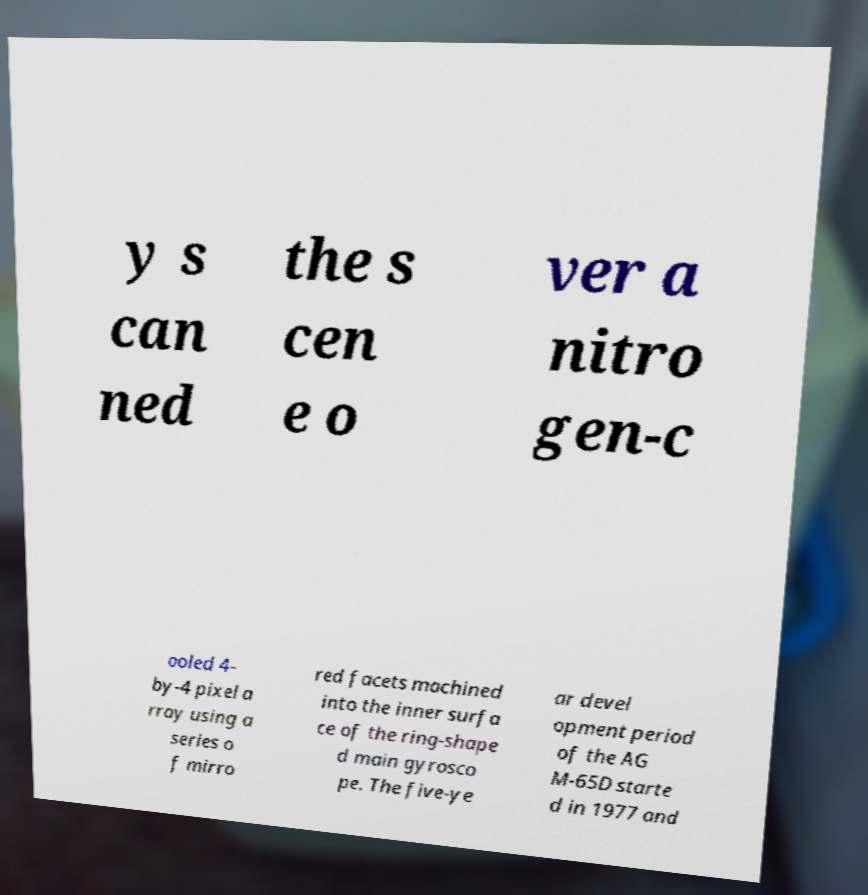Can you accurately transcribe the text from the provided image for me? y s can ned the s cen e o ver a nitro gen-c ooled 4- by-4 pixel a rray using a series o f mirro red facets machined into the inner surfa ce of the ring-shape d main gyrosco pe. The five-ye ar devel opment period of the AG M-65D starte d in 1977 and 